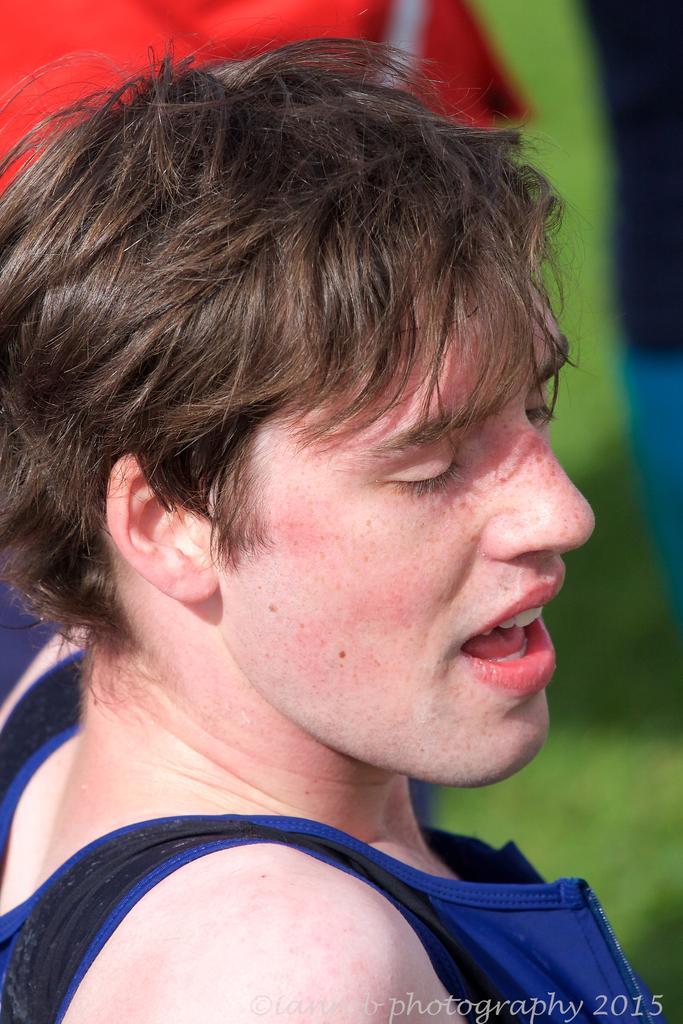How would you summarize this image in a sentence or two? In this image I can see a person. There is a blur background and at the bottom of the image there is a watermark. 